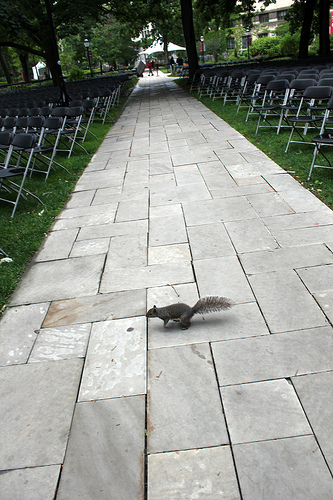<image>
Is the squirrel on the sidewalk? Yes. Looking at the image, I can see the squirrel is positioned on top of the sidewalk, with the sidewalk providing support. 